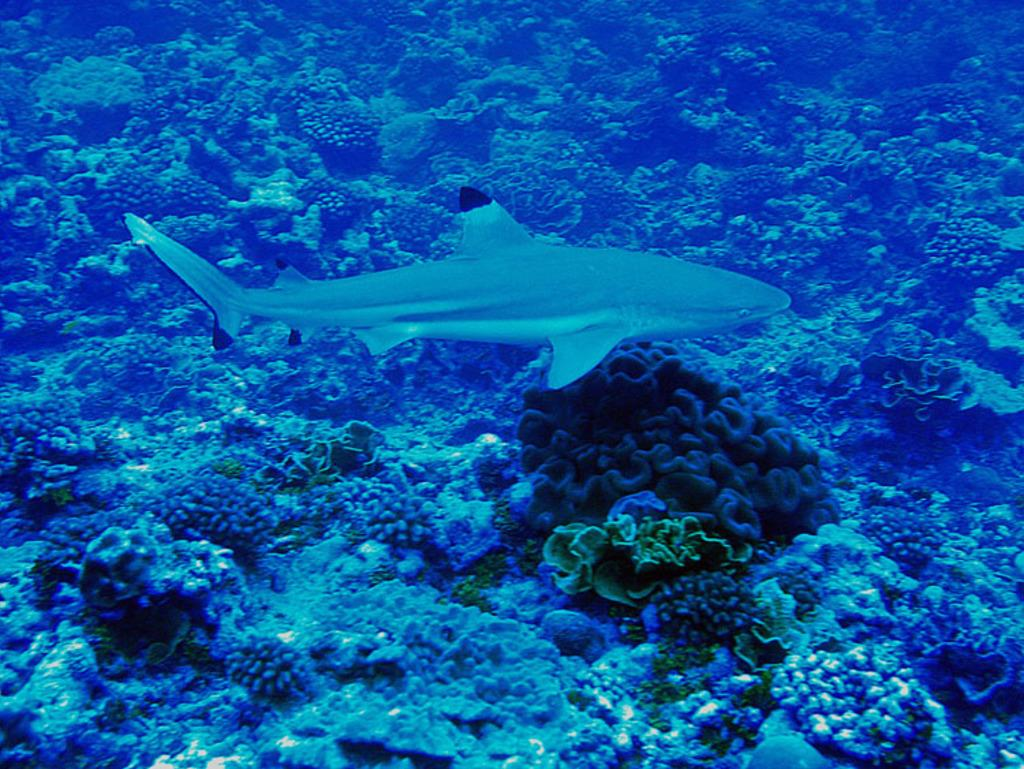What type of environment is shown in the image? The image depicts an underwater environment. What can be seen in the middle of the image? There is a fish in the middle of the image. What is located at the bottom of the image? There are plants at the bottom of the image. What type of unit is being measured by the fish in the image? There is no unit being measured by the fish in the image, as it is a fish in an underwater environment. 